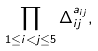Convert formula to latex. <formula><loc_0><loc_0><loc_500><loc_500>\prod _ { 1 \leq i < j \leq 5 } \Delta _ { i j } ^ { a _ { i j } } ,</formula> 